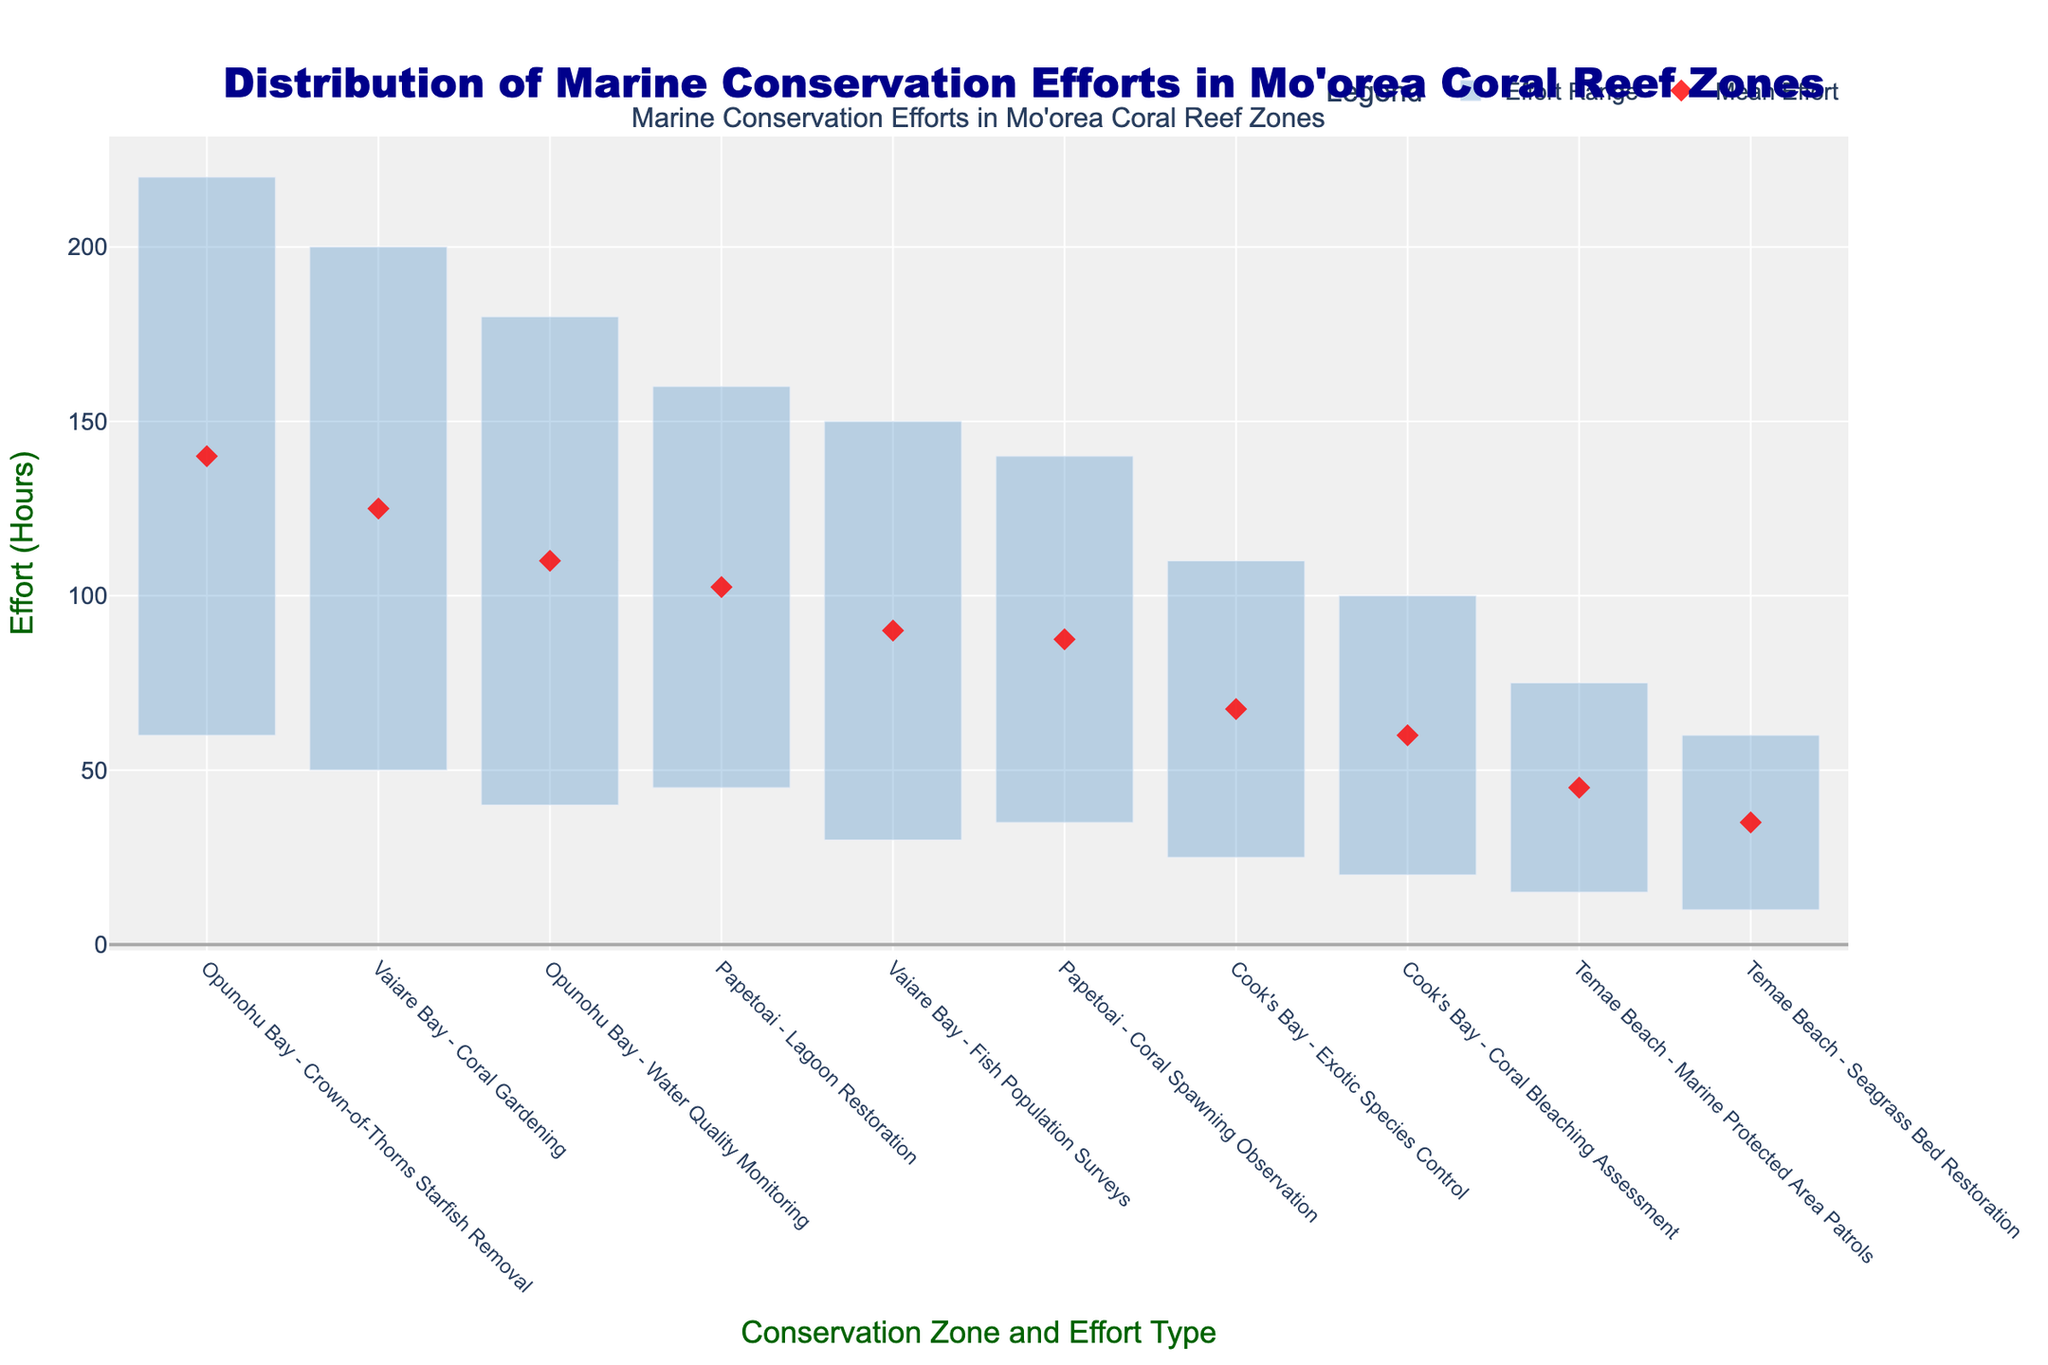What is the title of the plot? The title is positioned at the top of the plot, centered and formatted with a large font size.
Answer: Distribution of Marine Conservation Efforts in Mo'orea Coral Reef Zones Which conservation effort in Vaiare Bay has the highest maximum effort? By looking at the end of the blue bars for Vaiare Bay, we see the maximum value for "Crown-of-Thorns Starfish Removal" exceeds others.
Answer: Crown-of-Thorns Starfish Removal What is the average (mean) effort for Coral Gardening in Vaiare Bay? The mean effort is represented by the red diamond marker on the plot for Coral Gardening in Vaiare Bay.
Answer: 125 hours How much larger is the range of effort for Coral Bleaching Assessment in Cook's Bay compared to Seagrass Bed Restoration at Temae Beach? Calculate the range for each effort (100 - 20 for Coral Bleaching Assessment and 60 - 10 for Seagrass Bed Restoration) and then subtract the latter from the former.
Answer: 30 hours Which zone has the smallest minimum effort for any conservation effort? By examining the start of the blue bars, the smallest value is seen for Seagrass Bed Restoration at Temae Beach.
Answer: Temae Beach What is the difference in the mean effort between Fish Population Surveys in Vaiare Bay and Lagoon Restoration in Papetoai? Look at the red diamonds for each effort and subtract the mean effort for Lagoon Restoration from Fish Population Surveys (90 hours - 102.5 hours).
Answer: -12.5 hours Which zone has both the highest and the lowest mean efforts among all conservation efforts? Check the placement of red diamonds: Vaiare Bay has the highest (Coral Gardening), and Temae Beach has the lowest (Seagrass Bed Restoration).
Answer: Vaiare Bay and Temae Beach Compare the ranges of efforts between Water Quality Monitoring and Coral Spawning Observation. Which one has a larger range? Compute the range for both efforts (180 - 40 for Water Quality Monitoring and 140 - 35 for Coral Spawning Observation), then compare them.
Answer: Water Quality Monitoring In which zone is Lagoon Restoration conducted, and what is its minimum effort? Find the bar labeled "Lagoon Restoration" and see its minimum effort level on the y-axis.
Answer: Papetoai, 45 hours 